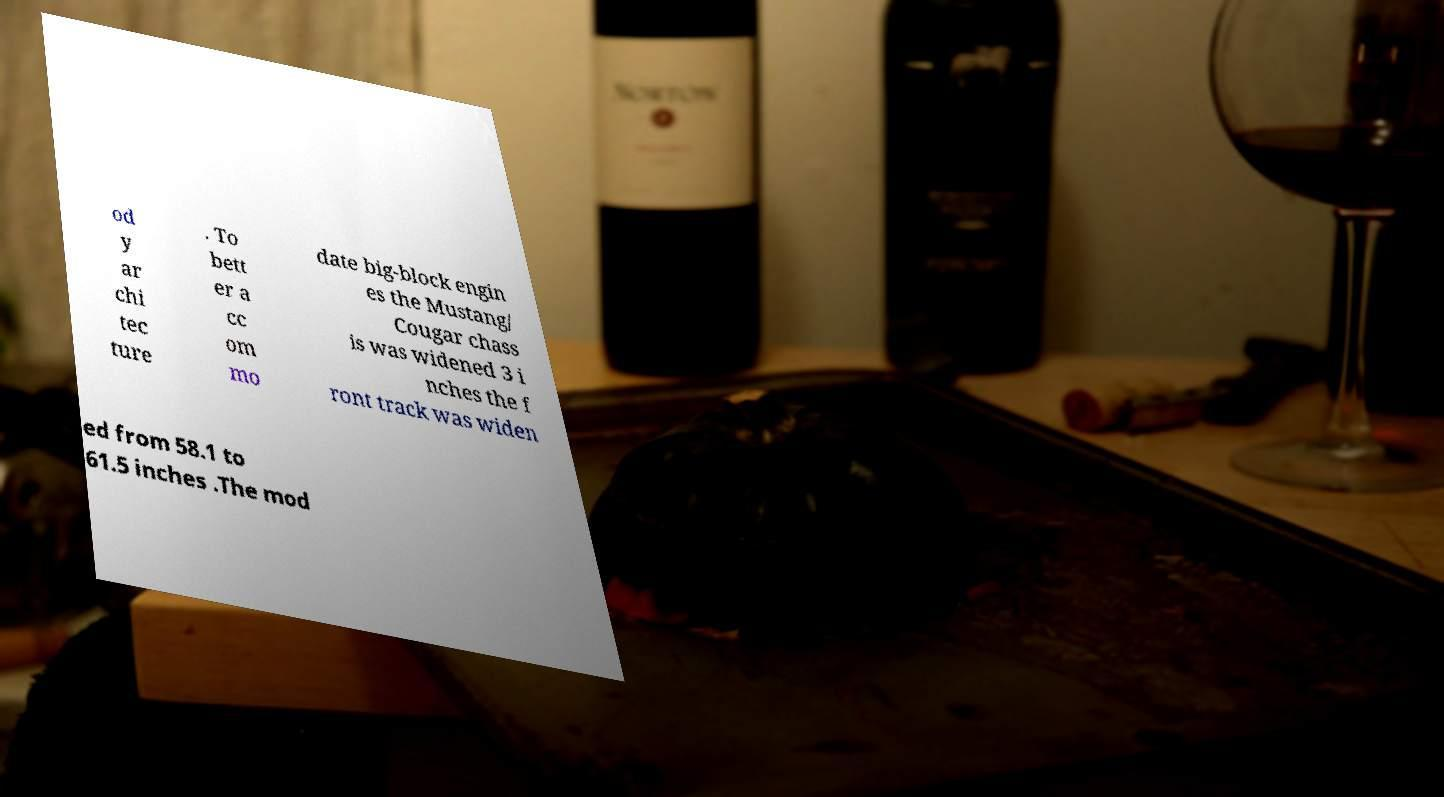Could you assist in decoding the text presented in this image and type it out clearly? od y ar chi tec ture . To bett er a cc om mo date big-block engin es the Mustang/ Cougar chass is was widened 3 i nches the f ront track was widen ed from 58.1 to 61.5 inches .The mod 